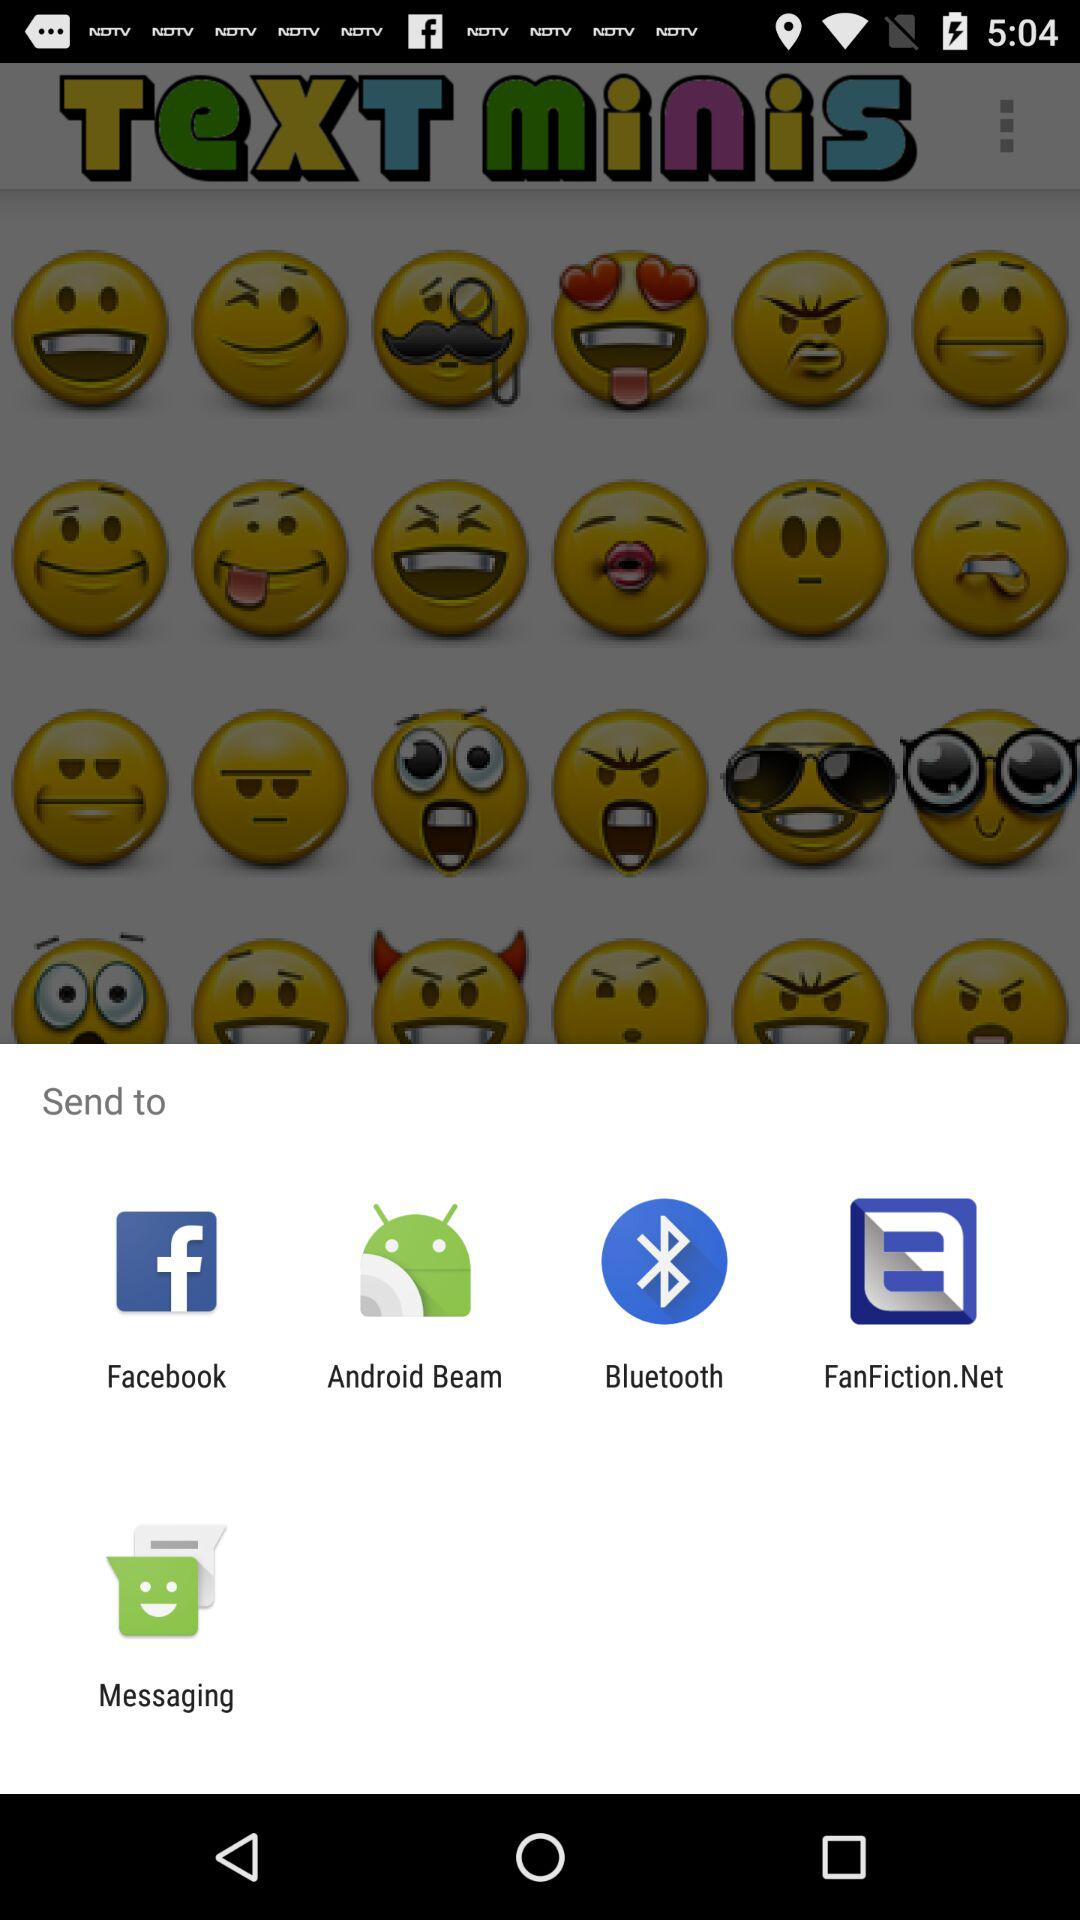Which applications can we send it to? We can send it to "Facebook", "Android Beam", "Bluetooth", "FanFiction.Net" and "Messaging". 